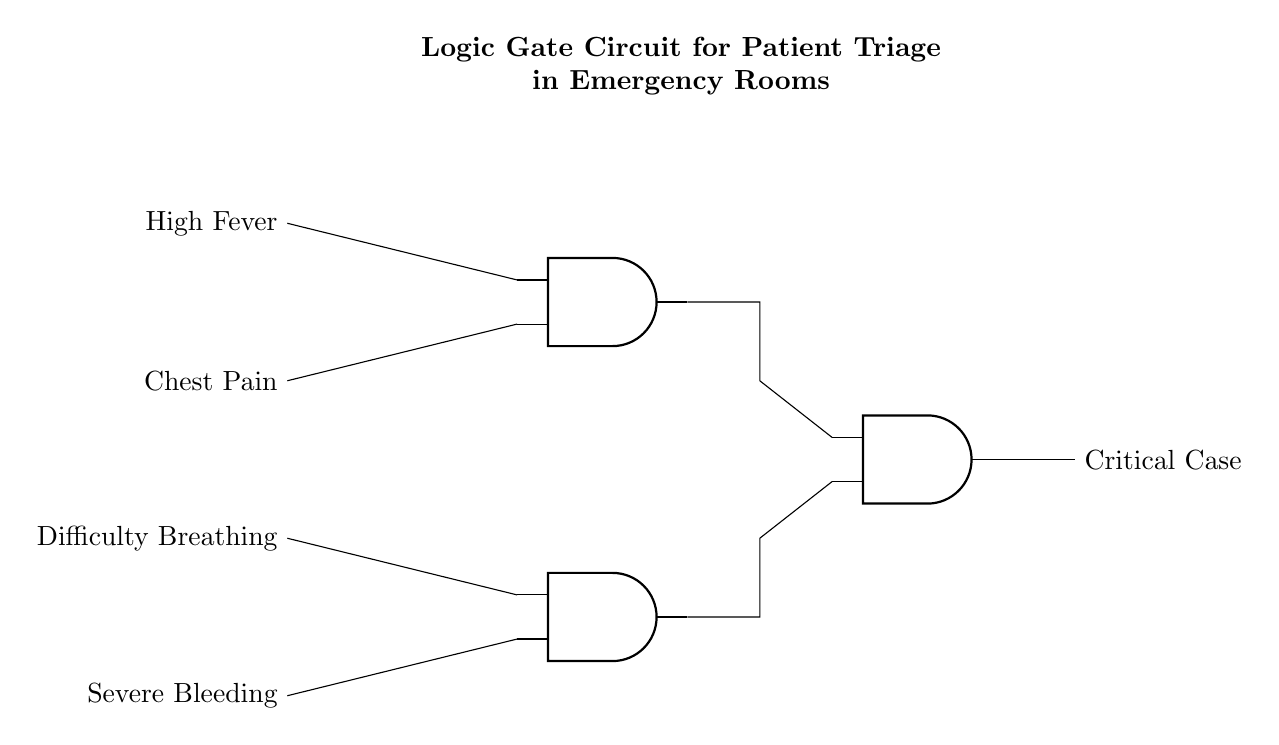What is the output of this circuit? The output of the circuit is labeled as "Critical Case," which signifies that if certain conditions are met through the input signals, the result will indicate a critical patient case.
Answer: Critical Case How many AND gates are in this circuit? The circuit diagram shows a total of three AND gates, which are used to process multiple input signals to determine the output.
Answer: Three What are the input conditions for the first AND gate? The first AND gate receives two inputs: "High Fever" and "Chest Pain," which need to both be present for the gate to output a signal.
Answer: High Fever and Chest Pain What will output if there is "Severe Bleeding" and "Difficulty Breathing"? The output will be evaluated through the second AND gate that takes "Severe Bleeding" and "Difficulty Breathing" as inputs. If both inputs are high, then the output of the second AND gate will be sent to the third AND gate.
Answer: Depends on input status Which two conditions are combined to evaluate the final output? The final output combines the results of the first AND gate ("High Fever" and "Chest Pain") and the second AND gate ("Severe Bleeding" and "Difficulty Breathing"). Both results need to be high to activate the third AND gate, leading to the output.
Answer: First and second AND gate outputs What is the significance of the connections in this circuit? The connections indicate how the input signals are routed through the AND gates, demonstrating the pathway for logic evaluation that ultimately leads to determining patient urgency in triage based on conditions present.
Answer: Prioritization of patient triage 